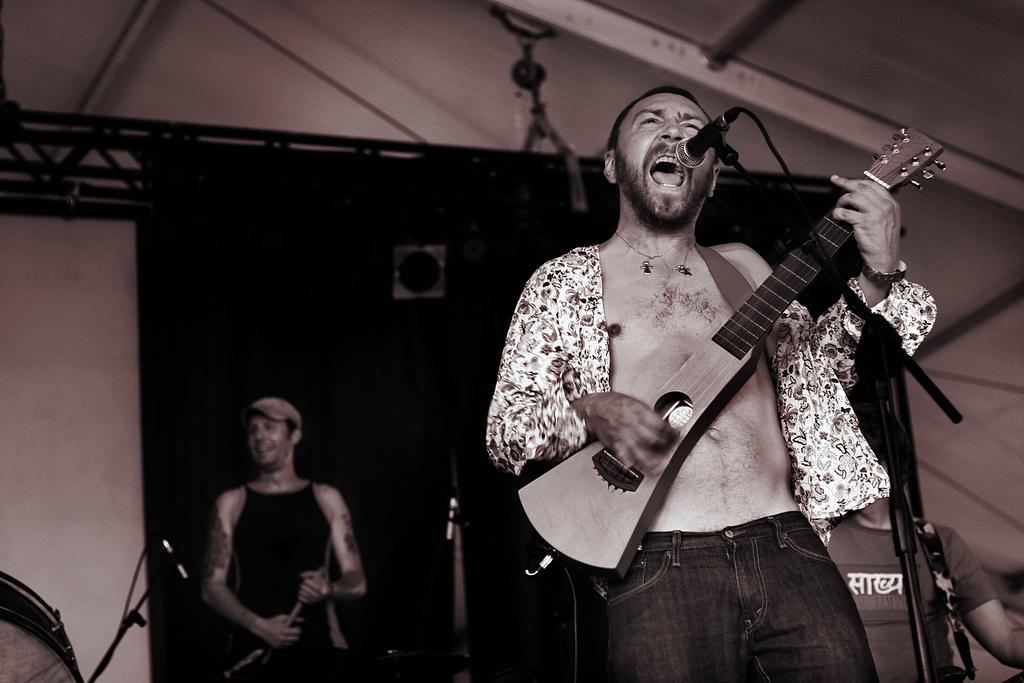What is the main activity of the person in the image? The person in the image is singing on a mic and playing a guitar. Are there any other musicians in the image? Yes, there are people playing musical instruments behind the singer. What can be seen hanging or displayed in the image? There is a banner visible in the image. How many dogs are visible in the image? There are no dogs present in the image. What type of crime is being committed in the image? There is no crime being committed in the image; it features a person singing and playing the guitar with other musicians. 